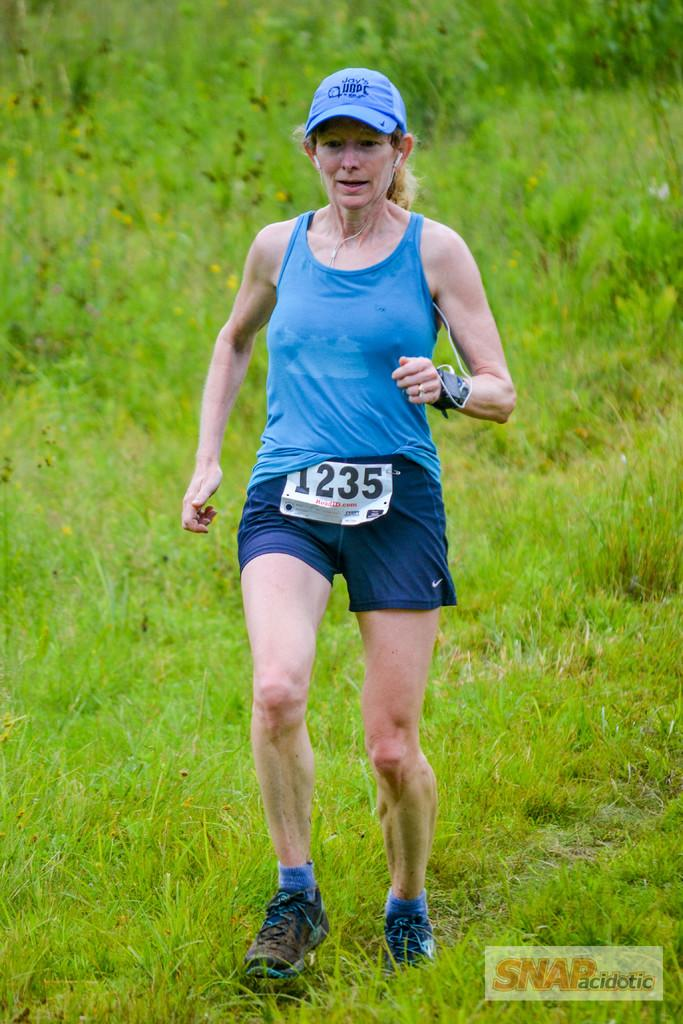<image>
Give a short and clear explanation of the subsequent image. The woman's cross country race number is 1235 and it is photographed by SNAP. 